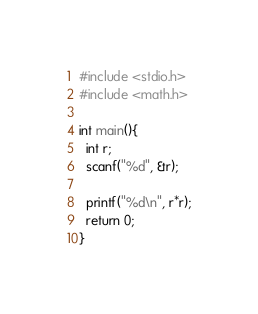<code> <loc_0><loc_0><loc_500><loc_500><_C_>#include <stdio.h>
#include <math.h>

int main(){
  int r;
  scanf("%d", &r);

  printf("%d\n", r*r);
  return 0;
}
</code> 